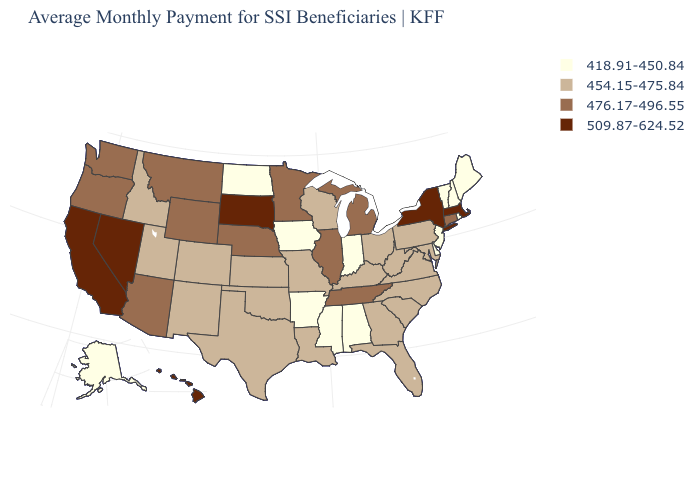Does Florida have a lower value than Alabama?
Short answer required. No. Name the states that have a value in the range 509.87-624.52?
Concise answer only. California, Hawaii, Massachusetts, Nevada, New York, South Dakota. What is the value of Arkansas?
Concise answer only. 418.91-450.84. What is the value of Delaware?
Write a very short answer. 418.91-450.84. What is the value of Connecticut?
Concise answer only. 476.17-496.55. Does Louisiana have the highest value in the USA?
Quick response, please. No. What is the lowest value in states that border Louisiana?
Keep it brief. 418.91-450.84. What is the highest value in the MidWest ?
Answer briefly. 509.87-624.52. Among the states that border Maryland , which have the lowest value?
Quick response, please. Delaware. Does Louisiana have a higher value than North Carolina?
Be succinct. No. What is the highest value in the Northeast ?
Write a very short answer. 509.87-624.52. Name the states that have a value in the range 418.91-450.84?
Short answer required. Alabama, Alaska, Arkansas, Delaware, Indiana, Iowa, Maine, Mississippi, New Hampshire, New Jersey, North Dakota, Rhode Island, Vermont. What is the value of Nevada?
Give a very brief answer. 509.87-624.52. What is the value of Nebraska?
Concise answer only. 476.17-496.55. What is the lowest value in the USA?
Keep it brief. 418.91-450.84. 